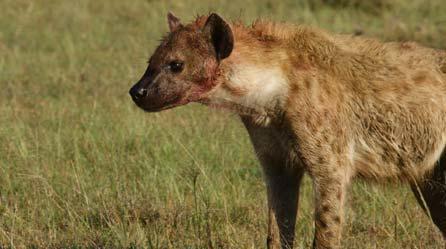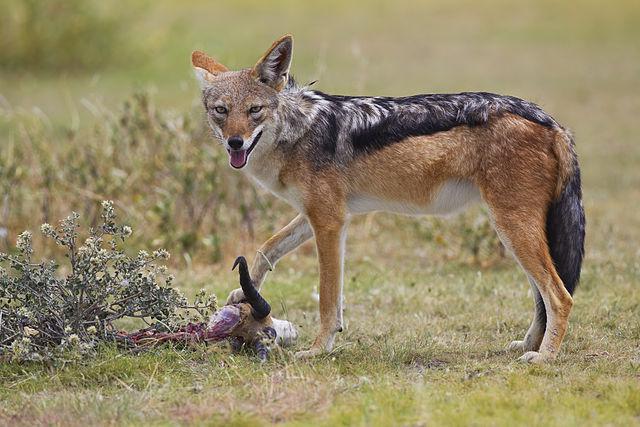The first image is the image on the left, the second image is the image on the right. For the images displayed, is the sentence "An image shows a wild dog with its meal of prey." factually correct? Answer yes or no. Yes. The first image is the image on the left, the second image is the image on the right. Analyze the images presented: Is the assertion "there are at least two hyenas in the image on the left" valid? Answer yes or no. No. 